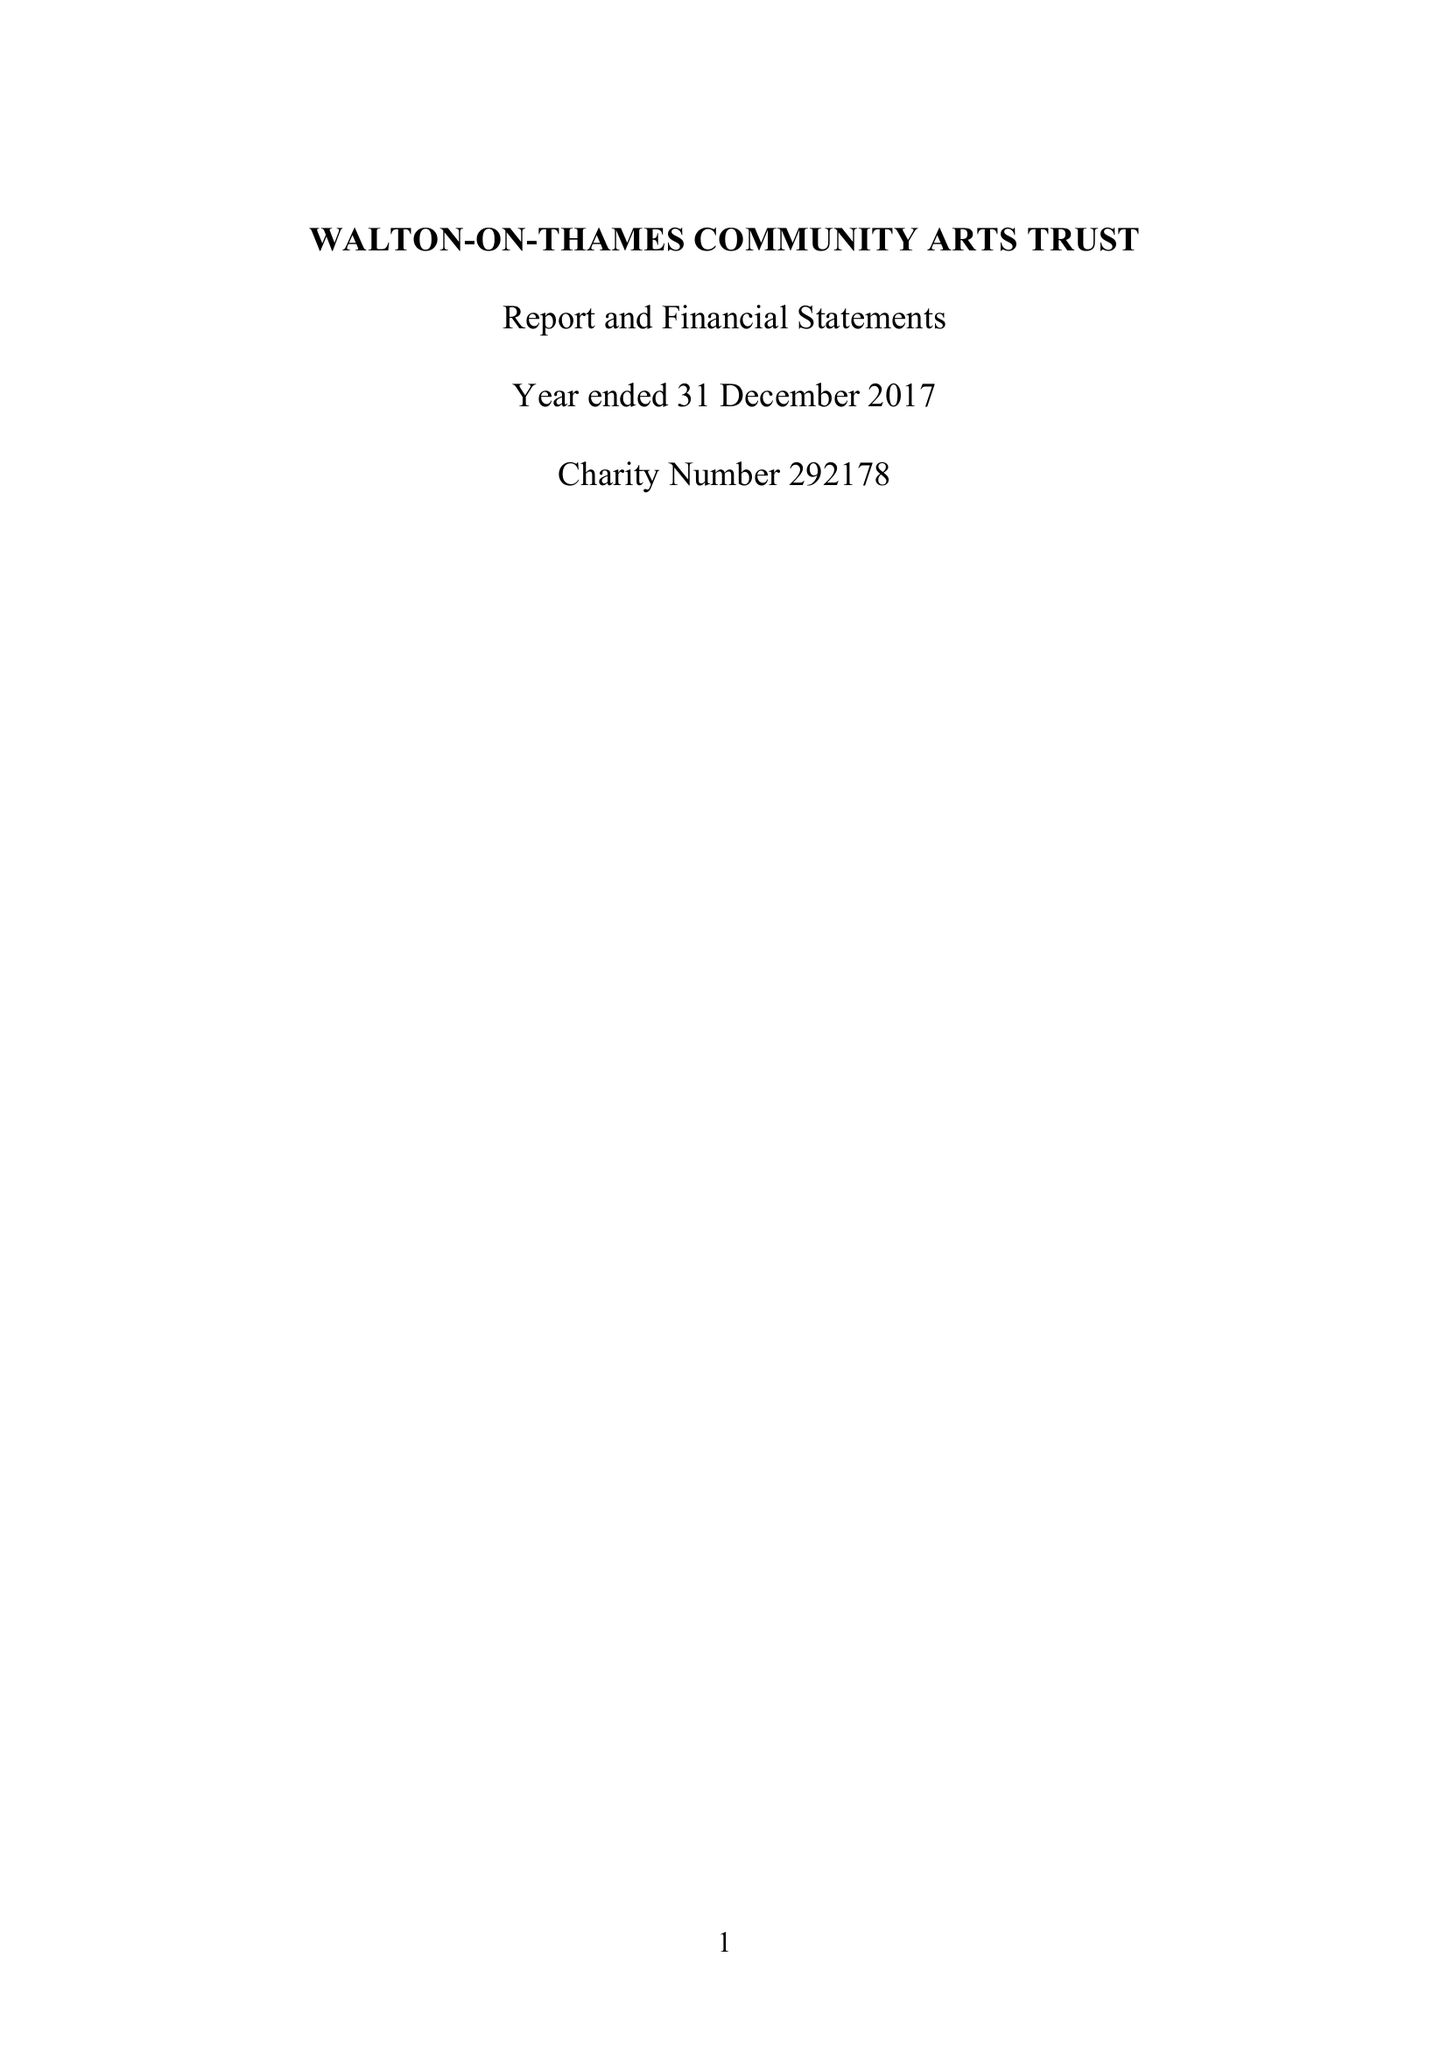What is the value for the address__street_line?
Answer the question using a single word or phrase. 29 RIVER MOUNT 